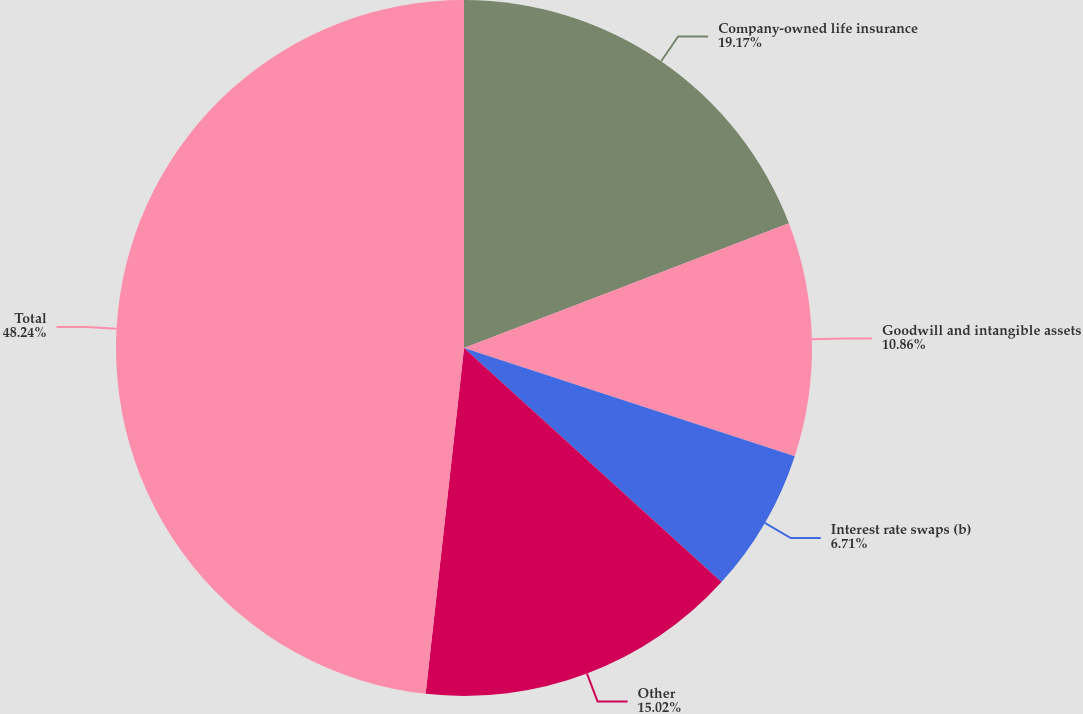Convert chart to OTSL. <chart><loc_0><loc_0><loc_500><loc_500><pie_chart><fcel>Company-owned life insurance<fcel>Goodwill and intangible assets<fcel>Interest rate swaps (b)<fcel>Other<fcel>Total<nl><fcel>19.17%<fcel>10.86%<fcel>6.71%<fcel>15.02%<fcel>48.24%<nl></chart> 